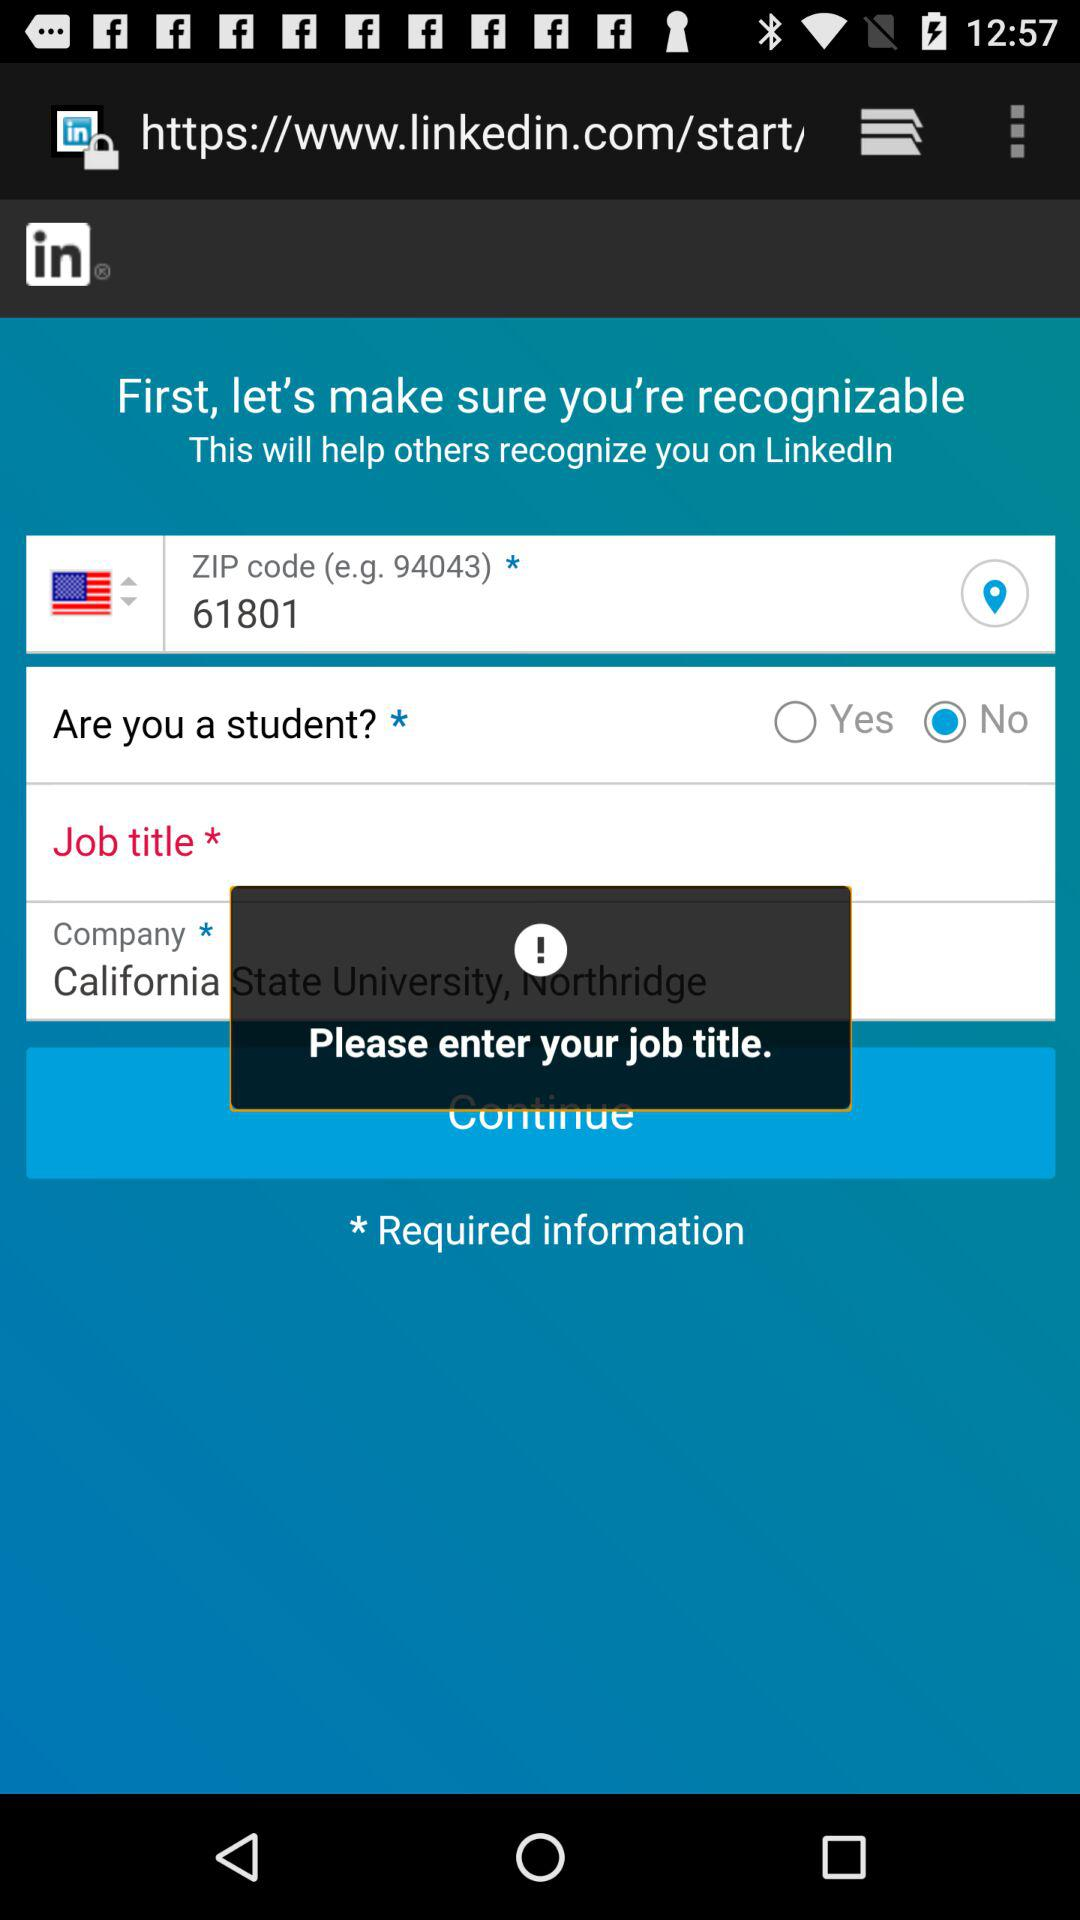What is the name of the application? The name of the application is "LinkedIn". 